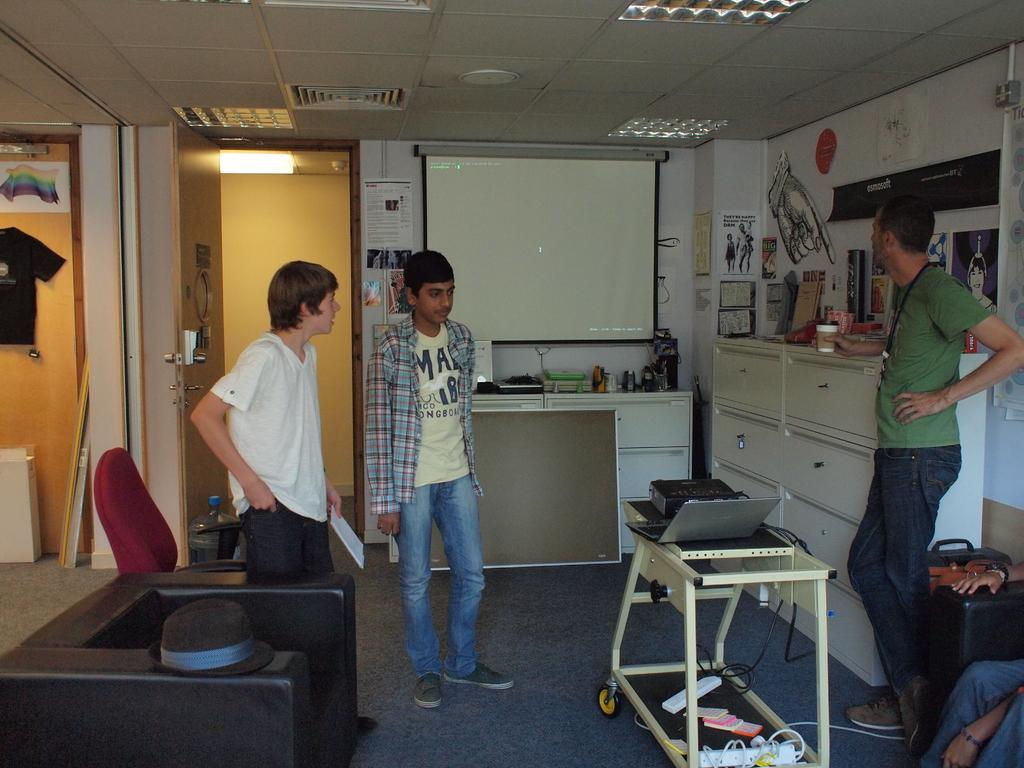In one or two sentences, can you explain what this image depicts? In this image I see 4 persons, in which these 3 men are standing and this person is sitting on a chair and there is a table over here, on which there is a laptop and few things on it and there is a hat on this couch, In the background i see a screen, a t-shirt over here, another chair, a van, cupboards, few things on it and papers on the wall and I see the light over here. 